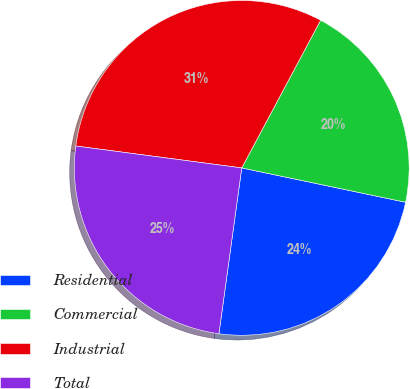Convert chart. <chart><loc_0><loc_0><loc_500><loc_500><pie_chart><fcel>Residential<fcel>Commercial<fcel>Industrial<fcel>Total<nl><fcel>23.89%<fcel>20.48%<fcel>30.72%<fcel>24.91%<nl></chart> 